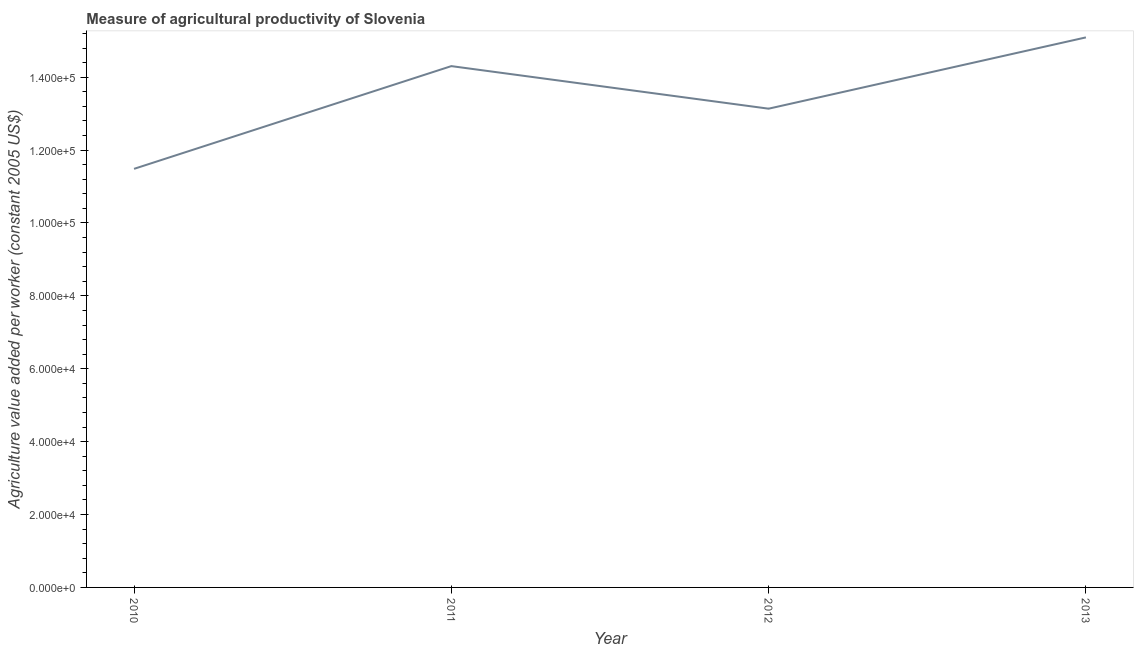What is the agriculture value added per worker in 2011?
Your answer should be compact. 1.43e+05. Across all years, what is the maximum agriculture value added per worker?
Keep it short and to the point. 1.51e+05. Across all years, what is the minimum agriculture value added per worker?
Provide a short and direct response. 1.15e+05. In which year was the agriculture value added per worker minimum?
Provide a short and direct response. 2010. What is the sum of the agriculture value added per worker?
Your answer should be compact. 5.40e+05. What is the difference between the agriculture value added per worker in 2010 and 2011?
Provide a short and direct response. -2.82e+04. What is the average agriculture value added per worker per year?
Offer a terse response. 1.35e+05. What is the median agriculture value added per worker?
Your response must be concise. 1.37e+05. In how many years, is the agriculture value added per worker greater than 64000 US$?
Provide a succinct answer. 4. What is the ratio of the agriculture value added per worker in 2010 to that in 2011?
Offer a very short reply. 0.8. Is the difference between the agriculture value added per worker in 2012 and 2013 greater than the difference between any two years?
Offer a terse response. No. What is the difference between the highest and the second highest agriculture value added per worker?
Offer a terse response. 7879.67. Is the sum of the agriculture value added per worker in 2012 and 2013 greater than the maximum agriculture value added per worker across all years?
Provide a short and direct response. Yes. What is the difference between the highest and the lowest agriculture value added per worker?
Your answer should be very brief. 3.61e+04. In how many years, is the agriculture value added per worker greater than the average agriculture value added per worker taken over all years?
Your answer should be compact. 2. Are the values on the major ticks of Y-axis written in scientific E-notation?
Give a very brief answer. Yes. Does the graph contain any zero values?
Your answer should be compact. No. What is the title of the graph?
Ensure brevity in your answer.  Measure of agricultural productivity of Slovenia. What is the label or title of the Y-axis?
Your response must be concise. Agriculture value added per worker (constant 2005 US$). What is the Agriculture value added per worker (constant 2005 US$) of 2010?
Your answer should be compact. 1.15e+05. What is the Agriculture value added per worker (constant 2005 US$) in 2011?
Your response must be concise. 1.43e+05. What is the Agriculture value added per worker (constant 2005 US$) of 2012?
Offer a very short reply. 1.31e+05. What is the Agriculture value added per worker (constant 2005 US$) of 2013?
Provide a short and direct response. 1.51e+05. What is the difference between the Agriculture value added per worker (constant 2005 US$) in 2010 and 2011?
Your answer should be compact. -2.82e+04. What is the difference between the Agriculture value added per worker (constant 2005 US$) in 2010 and 2012?
Your response must be concise. -1.65e+04. What is the difference between the Agriculture value added per worker (constant 2005 US$) in 2010 and 2013?
Ensure brevity in your answer.  -3.61e+04. What is the difference between the Agriculture value added per worker (constant 2005 US$) in 2011 and 2012?
Keep it short and to the point. 1.17e+04. What is the difference between the Agriculture value added per worker (constant 2005 US$) in 2011 and 2013?
Make the answer very short. -7879.67. What is the difference between the Agriculture value added per worker (constant 2005 US$) in 2012 and 2013?
Offer a terse response. -1.96e+04. What is the ratio of the Agriculture value added per worker (constant 2005 US$) in 2010 to that in 2011?
Your response must be concise. 0.8. What is the ratio of the Agriculture value added per worker (constant 2005 US$) in 2010 to that in 2012?
Your response must be concise. 0.87. What is the ratio of the Agriculture value added per worker (constant 2005 US$) in 2010 to that in 2013?
Ensure brevity in your answer.  0.76. What is the ratio of the Agriculture value added per worker (constant 2005 US$) in 2011 to that in 2012?
Provide a short and direct response. 1.09. What is the ratio of the Agriculture value added per worker (constant 2005 US$) in 2011 to that in 2013?
Your answer should be very brief. 0.95. What is the ratio of the Agriculture value added per worker (constant 2005 US$) in 2012 to that in 2013?
Provide a short and direct response. 0.87. 